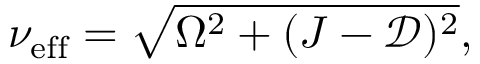<formula> <loc_0><loc_0><loc_500><loc_500>\nu _ { e f f } = \sqrt { \Omega ^ { 2 } + ( J - \mathcal { D } ) ^ { 2 } } ,</formula> 